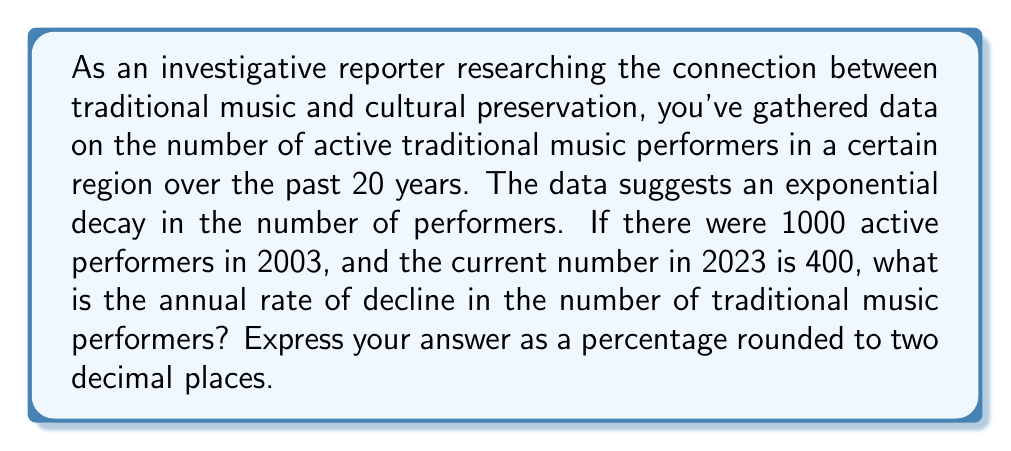Provide a solution to this math problem. To solve this problem, we'll use the exponential decay model:

$$N(t) = N_0 \cdot e^{-rt}$$

Where:
$N(t)$ is the number of performers at time $t$
$N_0$ is the initial number of performers
$r$ is the decay rate (which we need to find)
$t$ is the time elapsed in years

Given:
$N_0 = 1000$ (performers in 2003)
$N(20) = 400$ (performers in 2023, 20 years later)
$t = 20$ years

Let's plug these values into the equation:

$$400 = 1000 \cdot e^{-r \cdot 20}$$

Dividing both sides by 1000:

$$0.4 = e^{-20r}$$

Taking the natural logarithm of both sides:

$$\ln(0.4) = -20r$$

Solving for $r$:

$$r = -\frac{\ln(0.4)}{20}$$

$$r = \frac{\ln(2.5)}{20}$$ (since $\ln(0.4) = -\ln(2.5)$)

$$r \approx 0.0456$$

To convert this to a percentage, we multiply by 100:

$$\text{Percentage rate of decline} = r \times 100 \approx 4.56\%$$

Rounding to two decimal places, we get 4.56%.
Answer: 4.56% 